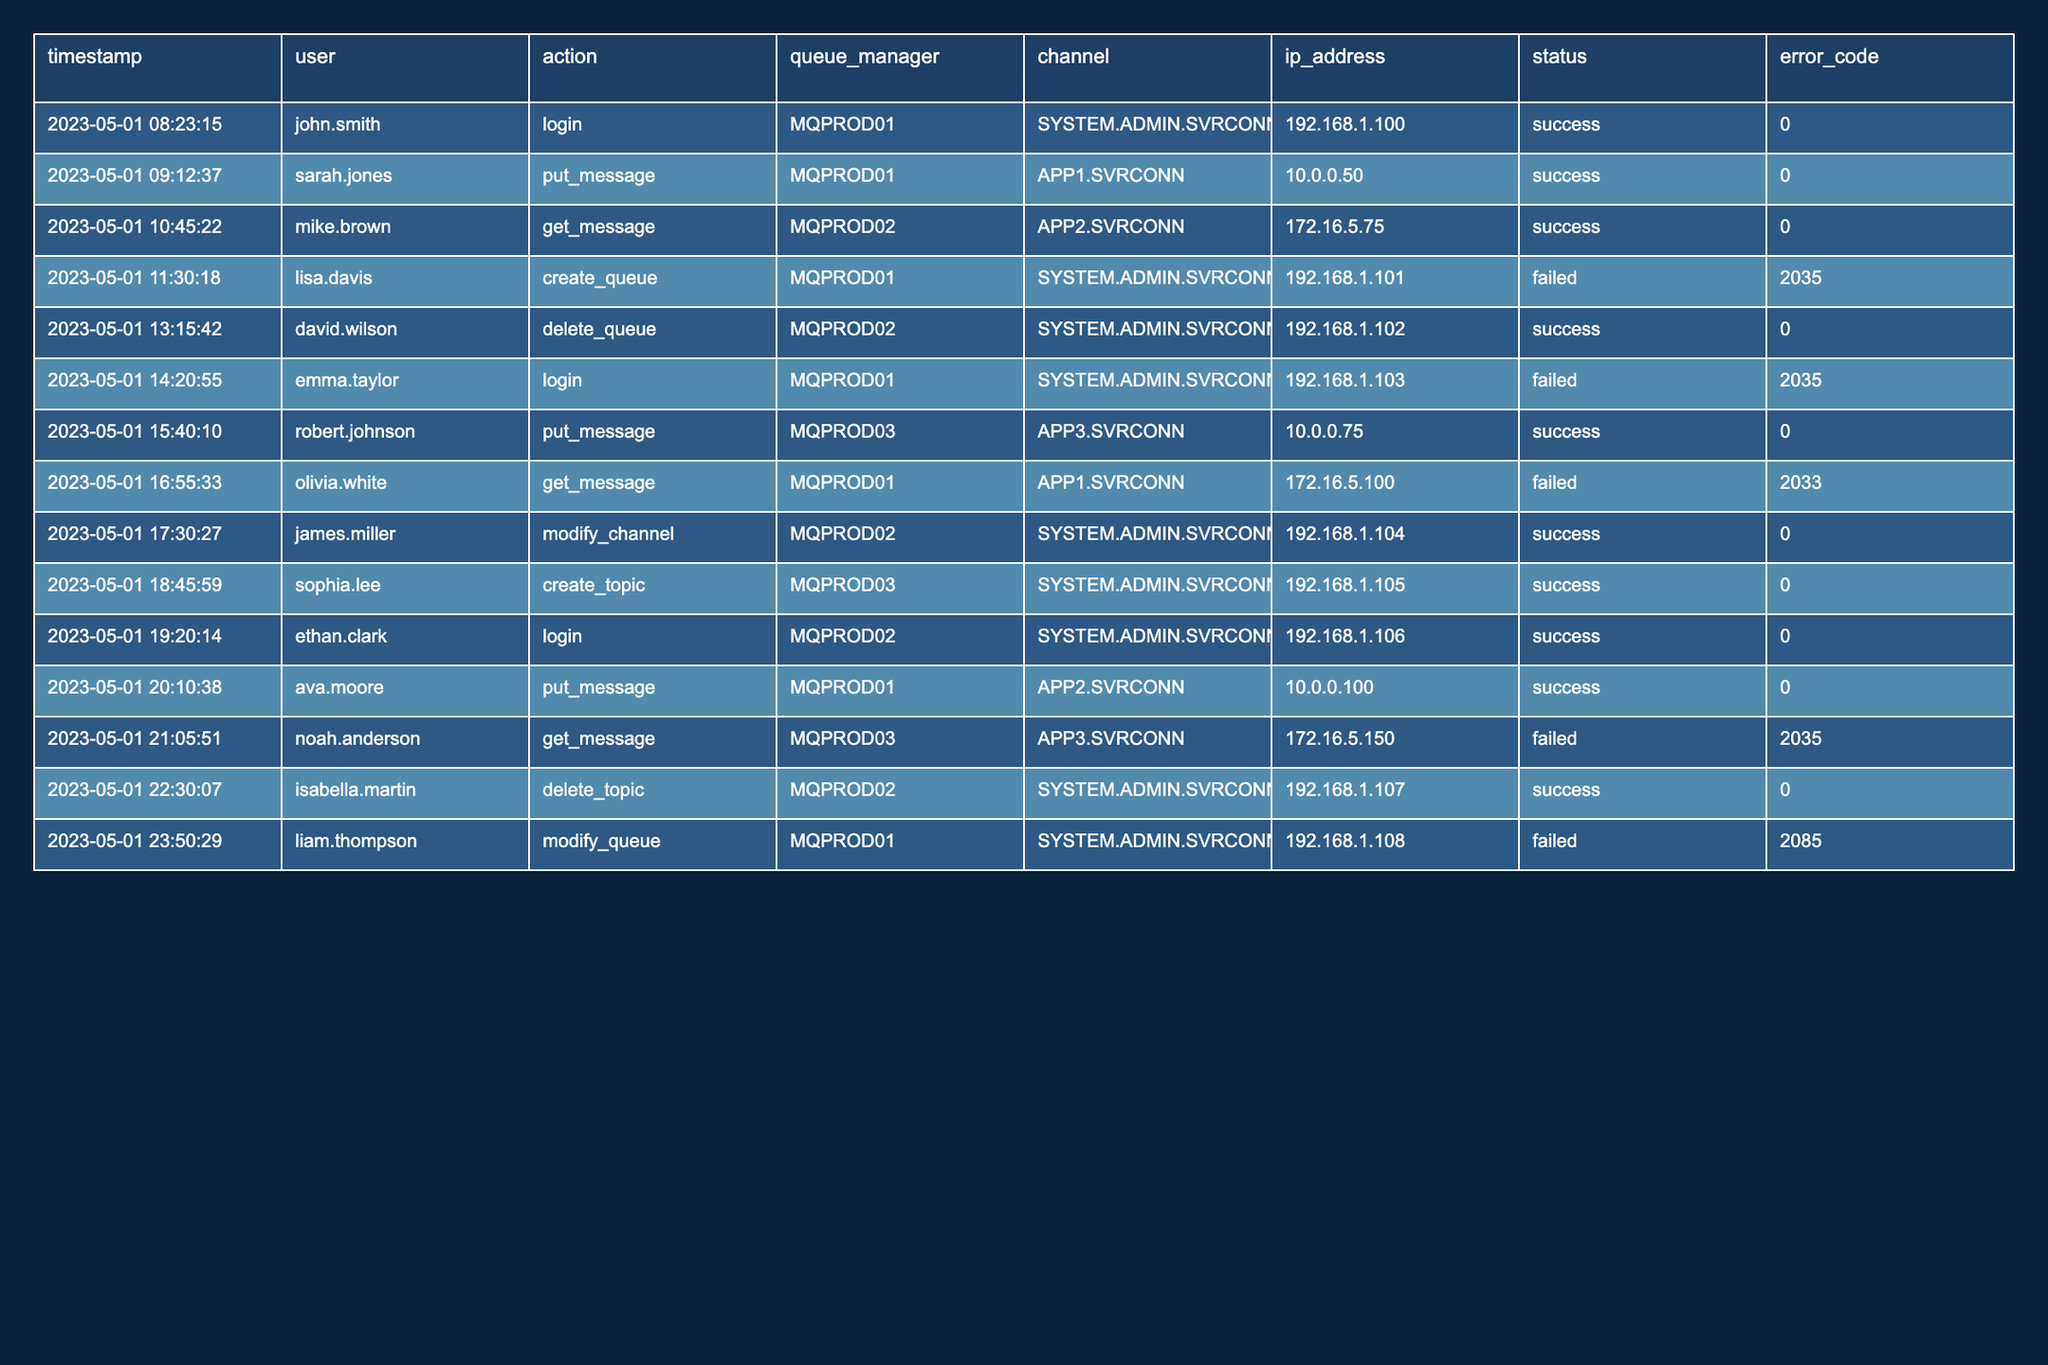What is the status of the action taken by lisa.davis? The action taken by lisa.davis was to create a queue on MQPROD01, and the status shows 'failed'.
Answer: failed How many successful actions were recorded in total? To determine the total number of successful actions, I count the rows where the status is 'success'. There are 9 successful actions.
Answer: 9 What is the error code for the action attempted by emma.taylor? The action attempted by emma.taylor was a login on MQPROD01, and the status shows 'failed' with an error code of 2035.
Answer: 2035 Which user attempted to delete a topic and was successful? The data shows that isabella.martin attempted to delete a topic on MQPROD02 and the status shows 'success'.
Answer: isabella.martin What is the most recent login attempt in the data? The most recent login attempt is by ethan.clark on 2023-05-01 at 19:20:14, and it was successful.
Answer: ethan.clark How many failed attempts occurred due to error code 2035? To find this, I count the occurrences of the error code 2035 in the 'error_code' column where the status is 'failed'. There are 3 occurrences of error code 2035.
Answer: 3 Was there any action that resulted in an error code of 2085? Looking through the table, the action taken by liam.thompson resulted in an error code of 2085 and it was a failed action to modify a queue.
Answer: Yes Which queue manager had the highest number of successful actions? I can tally the successful actions by queue manager. MQPROD01 had 4 successful actions, MQPROD02 had 2 successful actions, and MQPROD03 had 3 successful actions. Therefore, MQPROD01 has the highest count.
Answer: MQPROD01 What was the action taken by noah.anderson and was it successful? Noah.anderson attempted to get a message from MQPROD03, and the status shows 'failed'.
Answer: failed List all actions that were successful on MQPROD03. The successful actions on MQPROD03 include put_message by robert.johnson and create_topic by sophia.lee, making a total of 2 actions.
Answer: 2 actions 